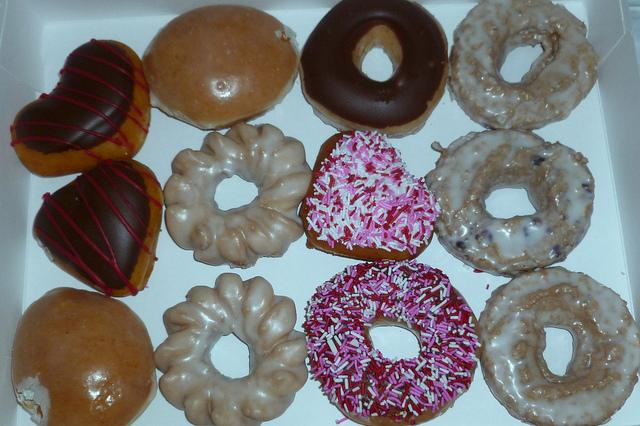How many of the dozen donuts could be cream-filled? Please explain your reasoning. five. There are five. 